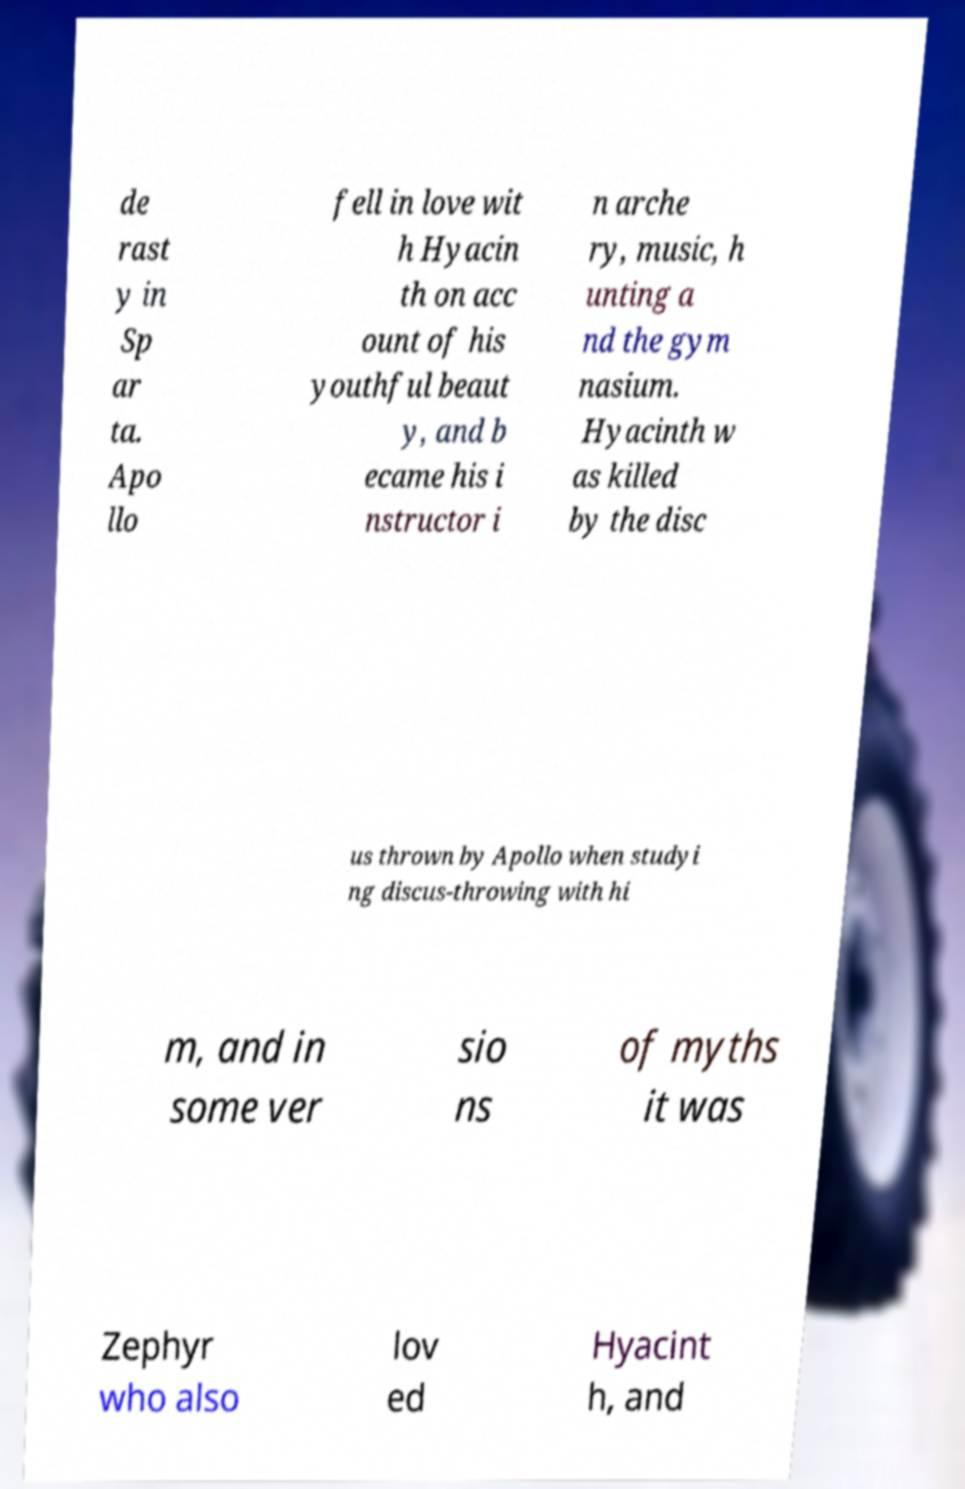There's text embedded in this image that I need extracted. Can you transcribe it verbatim? de rast y in Sp ar ta. Apo llo fell in love wit h Hyacin th on acc ount of his youthful beaut y, and b ecame his i nstructor i n arche ry, music, h unting a nd the gym nasium. Hyacinth w as killed by the disc us thrown by Apollo when studyi ng discus-throwing with hi m, and in some ver sio ns of myths it was Zephyr who also lov ed Hyacint h, and 